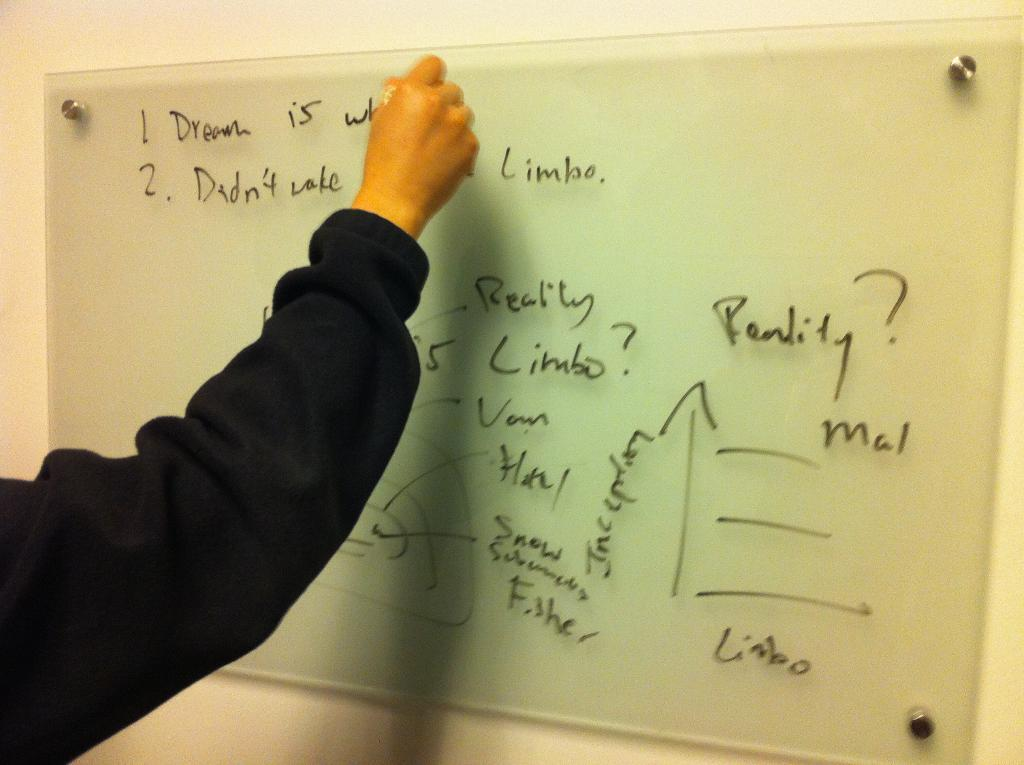<image>
Write a terse but informative summary of the picture. A person wearing a black top writes on a white board about reality, limbo and other philosophical terms. 